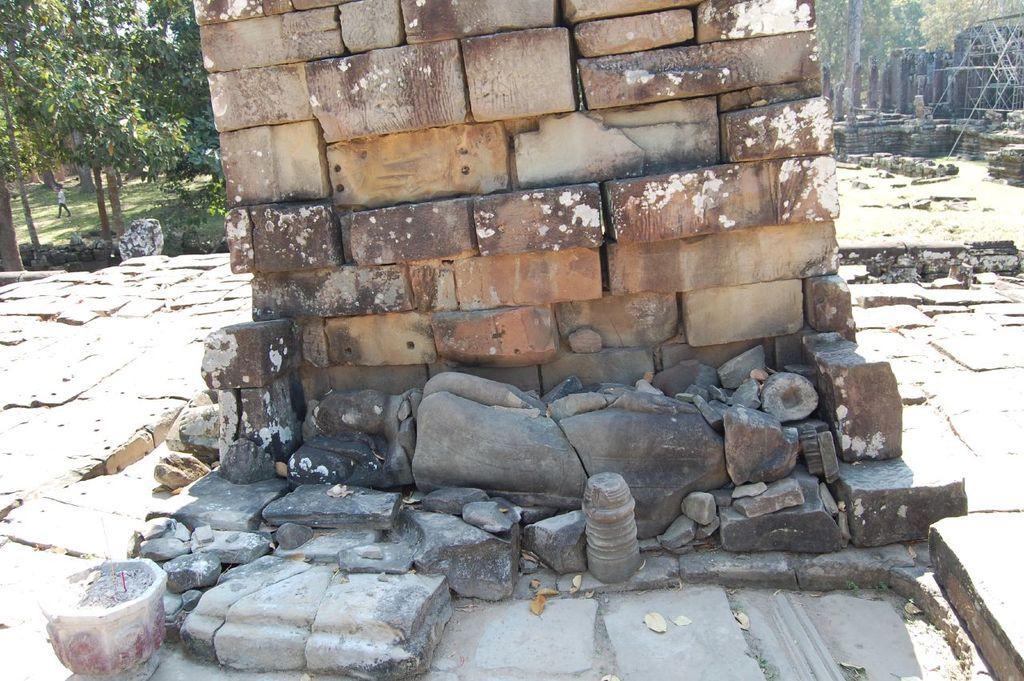In one or two sentences, can you explain what this image depicts? In this picture there is a stone wall in the center of the image and there are trees and flat stones in the background area of the image and there is a person in the image. 